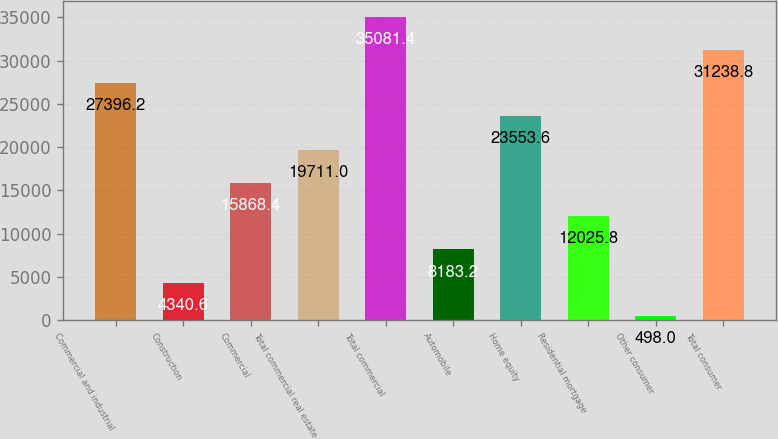Convert chart. <chart><loc_0><loc_0><loc_500><loc_500><bar_chart><fcel>Commercial and industrial<fcel>Construction<fcel>Commercial<fcel>Total commercial real estate<fcel>Total commercial<fcel>Automobile<fcel>Home equity<fcel>Residential mortgage<fcel>Other consumer<fcel>Total consumer<nl><fcel>27396.2<fcel>4340.6<fcel>15868.4<fcel>19711<fcel>35081.4<fcel>8183.2<fcel>23553.6<fcel>12025.8<fcel>498<fcel>31238.8<nl></chart> 